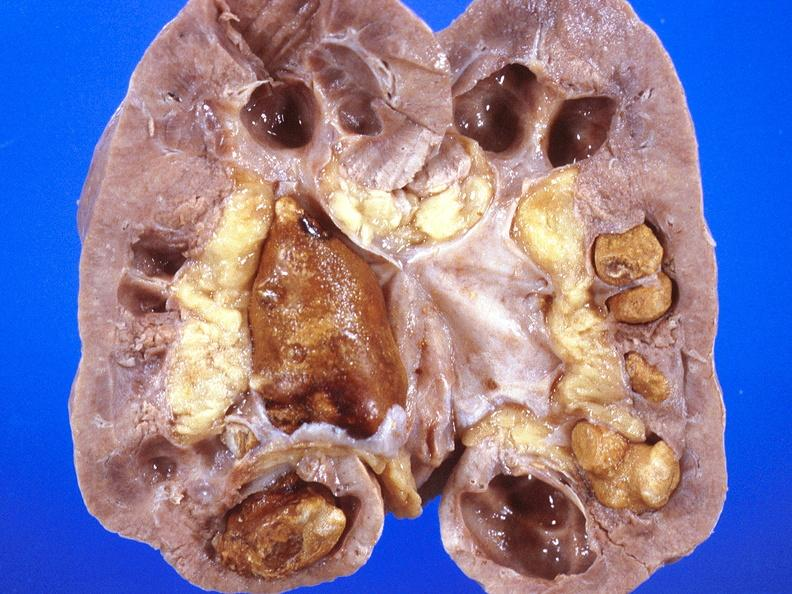what does this image show?
Answer the question using a single word or phrase. Renal pelvis 